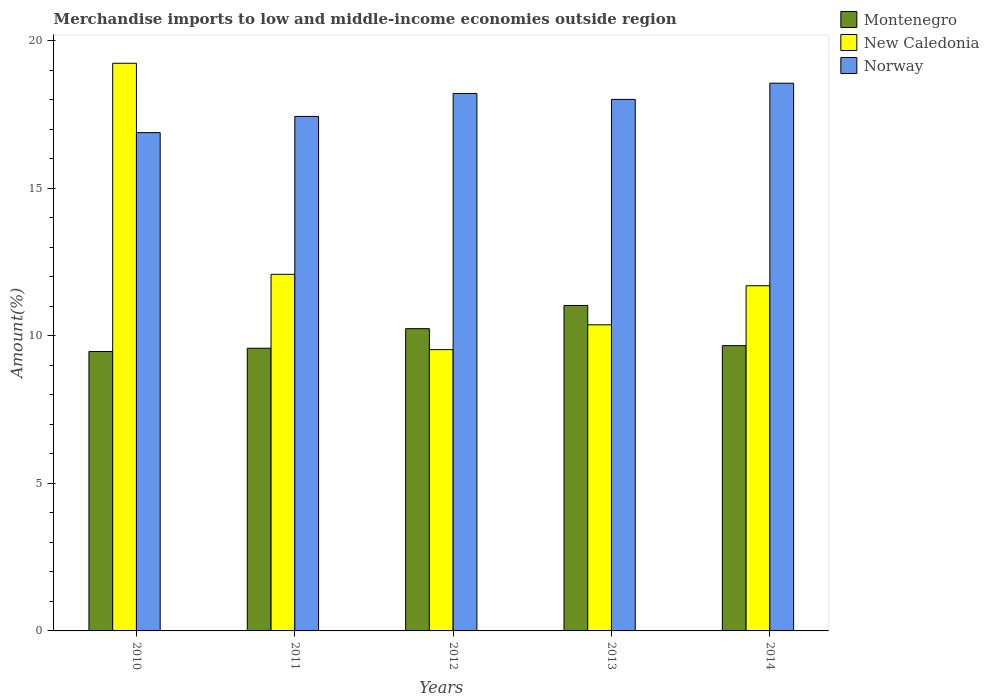How many different coloured bars are there?
Make the answer very short. 3. Are the number of bars on each tick of the X-axis equal?
Your answer should be very brief. Yes. What is the percentage of amount earned from merchandise imports in Montenegro in 2012?
Offer a terse response. 10.25. Across all years, what is the maximum percentage of amount earned from merchandise imports in Norway?
Provide a succinct answer. 18.57. Across all years, what is the minimum percentage of amount earned from merchandise imports in Montenegro?
Make the answer very short. 9.47. In which year was the percentage of amount earned from merchandise imports in Norway minimum?
Offer a terse response. 2010. What is the total percentage of amount earned from merchandise imports in Montenegro in the graph?
Give a very brief answer. 50.01. What is the difference between the percentage of amount earned from merchandise imports in Norway in 2012 and that in 2014?
Provide a succinct answer. -0.35. What is the difference between the percentage of amount earned from merchandise imports in Norway in 2011 and the percentage of amount earned from merchandise imports in Montenegro in 2012?
Give a very brief answer. 7.2. What is the average percentage of amount earned from merchandise imports in New Caledonia per year?
Your answer should be compact. 12.59. In the year 2013, what is the difference between the percentage of amount earned from merchandise imports in Norway and percentage of amount earned from merchandise imports in Montenegro?
Offer a terse response. 6.99. What is the ratio of the percentage of amount earned from merchandise imports in New Caledonia in 2012 to that in 2014?
Provide a succinct answer. 0.81. Is the difference between the percentage of amount earned from merchandise imports in Norway in 2011 and 2012 greater than the difference between the percentage of amount earned from merchandise imports in Montenegro in 2011 and 2012?
Provide a short and direct response. No. What is the difference between the highest and the second highest percentage of amount earned from merchandise imports in Norway?
Offer a very short reply. 0.35. What is the difference between the highest and the lowest percentage of amount earned from merchandise imports in New Caledonia?
Make the answer very short. 9.71. In how many years, is the percentage of amount earned from merchandise imports in Montenegro greater than the average percentage of amount earned from merchandise imports in Montenegro taken over all years?
Provide a succinct answer. 2. Is the sum of the percentage of amount earned from merchandise imports in Montenegro in 2011 and 2012 greater than the maximum percentage of amount earned from merchandise imports in Norway across all years?
Your answer should be compact. Yes. What does the 1st bar from the left in 2010 represents?
Offer a terse response. Montenegro. What does the 3rd bar from the right in 2014 represents?
Keep it short and to the point. Montenegro. Is it the case that in every year, the sum of the percentage of amount earned from merchandise imports in Norway and percentage of amount earned from merchandise imports in New Caledonia is greater than the percentage of amount earned from merchandise imports in Montenegro?
Your response must be concise. Yes. How many bars are there?
Keep it short and to the point. 15. Are all the bars in the graph horizontal?
Offer a terse response. No. What is the difference between two consecutive major ticks on the Y-axis?
Your answer should be very brief. 5. Are the values on the major ticks of Y-axis written in scientific E-notation?
Provide a succinct answer. No. Does the graph contain any zero values?
Offer a very short reply. No. Does the graph contain grids?
Offer a terse response. No. Where does the legend appear in the graph?
Provide a succinct answer. Top right. How are the legend labels stacked?
Your response must be concise. Vertical. What is the title of the graph?
Your answer should be very brief. Merchandise imports to low and middle-income economies outside region. What is the label or title of the Y-axis?
Offer a terse response. Amount(%). What is the Amount(%) in Montenegro in 2010?
Give a very brief answer. 9.47. What is the Amount(%) in New Caledonia in 2010?
Ensure brevity in your answer.  19.25. What is the Amount(%) of Norway in 2010?
Keep it short and to the point. 16.89. What is the Amount(%) of Montenegro in 2011?
Your answer should be compact. 9.58. What is the Amount(%) in New Caledonia in 2011?
Offer a terse response. 12.09. What is the Amount(%) of Norway in 2011?
Provide a succinct answer. 17.44. What is the Amount(%) in Montenegro in 2012?
Your answer should be very brief. 10.25. What is the Amount(%) in New Caledonia in 2012?
Your answer should be compact. 9.54. What is the Amount(%) in Norway in 2012?
Your answer should be compact. 18.22. What is the Amount(%) of Montenegro in 2013?
Keep it short and to the point. 11.03. What is the Amount(%) in New Caledonia in 2013?
Your answer should be very brief. 10.38. What is the Amount(%) in Norway in 2013?
Provide a succinct answer. 18.02. What is the Amount(%) of Montenegro in 2014?
Offer a terse response. 9.67. What is the Amount(%) in New Caledonia in 2014?
Give a very brief answer. 11.7. What is the Amount(%) of Norway in 2014?
Keep it short and to the point. 18.57. Across all years, what is the maximum Amount(%) in Montenegro?
Give a very brief answer. 11.03. Across all years, what is the maximum Amount(%) of New Caledonia?
Your answer should be very brief. 19.25. Across all years, what is the maximum Amount(%) in Norway?
Offer a very short reply. 18.57. Across all years, what is the minimum Amount(%) in Montenegro?
Offer a terse response. 9.47. Across all years, what is the minimum Amount(%) of New Caledonia?
Your response must be concise. 9.54. Across all years, what is the minimum Amount(%) in Norway?
Make the answer very short. 16.89. What is the total Amount(%) of Montenegro in the graph?
Your answer should be very brief. 50.01. What is the total Amount(%) in New Caledonia in the graph?
Your answer should be compact. 62.95. What is the total Amount(%) of Norway in the graph?
Your answer should be compact. 89.15. What is the difference between the Amount(%) of Montenegro in 2010 and that in 2011?
Your answer should be very brief. -0.11. What is the difference between the Amount(%) in New Caledonia in 2010 and that in 2011?
Ensure brevity in your answer.  7.16. What is the difference between the Amount(%) in Norway in 2010 and that in 2011?
Give a very brief answer. -0.55. What is the difference between the Amount(%) in Montenegro in 2010 and that in 2012?
Offer a terse response. -0.77. What is the difference between the Amount(%) in New Caledonia in 2010 and that in 2012?
Your response must be concise. 9.71. What is the difference between the Amount(%) of Norway in 2010 and that in 2012?
Your response must be concise. -1.33. What is the difference between the Amount(%) of Montenegro in 2010 and that in 2013?
Keep it short and to the point. -1.56. What is the difference between the Amount(%) of New Caledonia in 2010 and that in 2013?
Ensure brevity in your answer.  8.87. What is the difference between the Amount(%) in Norway in 2010 and that in 2013?
Your answer should be very brief. -1.13. What is the difference between the Amount(%) of Montenegro in 2010 and that in 2014?
Provide a short and direct response. -0.2. What is the difference between the Amount(%) in New Caledonia in 2010 and that in 2014?
Offer a very short reply. 7.54. What is the difference between the Amount(%) in Norway in 2010 and that in 2014?
Make the answer very short. -1.68. What is the difference between the Amount(%) of Montenegro in 2011 and that in 2012?
Your answer should be very brief. -0.66. What is the difference between the Amount(%) of New Caledonia in 2011 and that in 2012?
Your answer should be very brief. 2.55. What is the difference between the Amount(%) in Norway in 2011 and that in 2012?
Your answer should be very brief. -0.78. What is the difference between the Amount(%) in Montenegro in 2011 and that in 2013?
Offer a very short reply. -1.45. What is the difference between the Amount(%) of New Caledonia in 2011 and that in 2013?
Provide a short and direct response. 1.71. What is the difference between the Amount(%) in Norway in 2011 and that in 2013?
Provide a succinct answer. -0.58. What is the difference between the Amount(%) in Montenegro in 2011 and that in 2014?
Your answer should be very brief. -0.09. What is the difference between the Amount(%) of New Caledonia in 2011 and that in 2014?
Give a very brief answer. 0.39. What is the difference between the Amount(%) of Norway in 2011 and that in 2014?
Make the answer very short. -1.13. What is the difference between the Amount(%) of Montenegro in 2012 and that in 2013?
Your answer should be very brief. -0.79. What is the difference between the Amount(%) in New Caledonia in 2012 and that in 2013?
Your answer should be very brief. -0.84. What is the difference between the Amount(%) of Norway in 2012 and that in 2013?
Your answer should be very brief. 0.2. What is the difference between the Amount(%) in Montenegro in 2012 and that in 2014?
Offer a very short reply. 0.58. What is the difference between the Amount(%) of New Caledonia in 2012 and that in 2014?
Make the answer very short. -2.17. What is the difference between the Amount(%) of Norway in 2012 and that in 2014?
Ensure brevity in your answer.  -0.35. What is the difference between the Amount(%) of Montenegro in 2013 and that in 2014?
Offer a very short reply. 1.36. What is the difference between the Amount(%) of New Caledonia in 2013 and that in 2014?
Provide a succinct answer. -1.32. What is the difference between the Amount(%) in Norway in 2013 and that in 2014?
Make the answer very short. -0.55. What is the difference between the Amount(%) of Montenegro in 2010 and the Amount(%) of New Caledonia in 2011?
Ensure brevity in your answer.  -2.62. What is the difference between the Amount(%) of Montenegro in 2010 and the Amount(%) of Norway in 2011?
Provide a short and direct response. -7.97. What is the difference between the Amount(%) in New Caledonia in 2010 and the Amount(%) in Norway in 2011?
Your response must be concise. 1.8. What is the difference between the Amount(%) of Montenegro in 2010 and the Amount(%) of New Caledonia in 2012?
Ensure brevity in your answer.  -0.06. What is the difference between the Amount(%) of Montenegro in 2010 and the Amount(%) of Norway in 2012?
Keep it short and to the point. -8.75. What is the difference between the Amount(%) in New Caledonia in 2010 and the Amount(%) in Norway in 2012?
Provide a succinct answer. 1.02. What is the difference between the Amount(%) of Montenegro in 2010 and the Amount(%) of New Caledonia in 2013?
Your answer should be compact. -0.9. What is the difference between the Amount(%) of Montenegro in 2010 and the Amount(%) of Norway in 2013?
Give a very brief answer. -8.55. What is the difference between the Amount(%) in New Caledonia in 2010 and the Amount(%) in Norway in 2013?
Your response must be concise. 1.22. What is the difference between the Amount(%) of Montenegro in 2010 and the Amount(%) of New Caledonia in 2014?
Provide a succinct answer. -2.23. What is the difference between the Amount(%) of Montenegro in 2010 and the Amount(%) of Norway in 2014?
Ensure brevity in your answer.  -9.1. What is the difference between the Amount(%) in New Caledonia in 2010 and the Amount(%) in Norway in 2014?
Give a very brief answer. 0.68. What is the difference between the Amount(%) of Montenegro in 2011 and the Amount(%) of New Caledonia in 2012?
Provide a succinct answer. 0.05. What is the difference between the Amount(%) in Montenegro in 2011 and the Amount(%) in Norway in 2012?
Offer a very short reply. -8.64. What is the difference between the Amount(%) of New Caledonia in 2011 and the Amount(%) of Norway in 2012?
Your answer should be compact. -6.13. What is the difference between the Amount(%) in Montenegro in 2011 and the Amount(%) in New Caledonia in 2013?
Give a very brief answer. -0.79. What is the difference between the Amount(%) of Montenegro in 2011 and the Amount(%) of Norway in 2013?
Offer a terse response. -8.44. What is the difference between the Amount(%) of New Caledonia in 2011 and the Amount(%) of Norway in 2013?
Keep it short and to the point. -5.93. What is the difference between the Amount(%) in Montenegro in 2011 and the Amount(%) in New Caledonia in 2014?
Make the answer very short. -2.12. What is the difference between the Amount(%) in Montenegro in 2011 and the Amount(%) in Norway in 2014?
Your answer should be very brief. -8.98. What is the difference between the Amount(%) in New Caledonia in 2011 and the Amount(%) in Norway in 2014?
Your answer should be very brief. -6.48. What is the difference between the Amount(%) in Montenegro in 2012 and the Amount(%) in New Caledonia in 2013?
Give a very brief answer. -0.13. What is the difference between the Amount(%) in Montenegro in 2012 and the Amount(%) in Norway in 2013?
Give a very brief answer. -7.77. What is the difference between the Amount(%) in New Caledonia in 2012 and the Amount(%) in Norway in 2013?
Offer a very short reply. -8.48. What is the difference between the Amount(%) in Montenegro in 2012 and the Amount(%) in New Caledonia in 2014?
Your answer should be very brief. -1.46. What is the difference between the Amount(%) of Montenegro in 2012 and the Amount(%) of Norway in 2014?
Offer a terse response. -8.32. What is the difference between the Amount(%) of New Caledonia in 2012 and the Amount(%) of Norway in 2014?
Ensure brevity in your answer.  -9.03. What is the difference between the Amount(%) of Montenegro in 2013 and the Amount(%) of New Caledonia in 2014?
Provide a short and direct response. -0.67. What is the difference between the Amount(%) of Montenegro in 2013 and the Amount(%) of Norway in 2014?
Your answer should be compact. -7.54. What is the difference between the Amount(%) of New Caledonia in 2013 and the Amount(%) of Norway in 2014?
Provide a short and direct response. -8.19. What is the average Amount(%) in Montenegro per year?
Offer a very short reply. 10. What is the average Amount(%) of New Caledonia per year?
Your response must be concise. 12.59. What is the average Amount(%) in Norway per year?
Make the answer very short. 17.83. In the year 2010, what is the difference between the Amount(%) in Montenegro and Amount(%) in New Caledonia?
Your answer should be compact. -9.77. In the year 2010, what is the difference between the Amount(%) in Montenegro and Amount(%) in Norway?
Keep it short and to the point. -7.42. In the year 2010, what is the difference between the Amount(%) of New Caledonia and Amount(%) of Norway?
Your answer should be compact. 2.35. In the year 2011, what is the difference between the Amount(%) in Montenegro and Amount(%) in New Caledonia?
Keep it short and to the point. -2.51. In the year 2011, what is the difference between the Amount(%) in Montenegro and Amount(%) in Norway?
Ensure brevity in your answer.  -7.86. In the year 2011, what is the difference between the Amount(%) in New Caledonia and Amount(%) in Norway?
Your answer should be very brief. -5.35. In the year 2012, what is the difference between the Amount(%) of Montenegro and Amount(%) of New Caledonia?
Ensure brevity in your answer.  0.71. In the year 2012, what is the difference between the Amount(%) of Montenegro and Amount(%) of Norway?
Offer a very short reply. -7.97. In the year 2012, what is the difference between the Amount(%) in New Caledonia and Amount(%) in Norway?
Keep it short and to the point. -8.68. In the year 2013, what is the difference between the Amount(%) of Montenegro and Amount(%) of New Caledonia?
Keep it short and to the point. 0.66. In the year 2013, what is the difference between the Amount(%) of Montenegro and Amount(%) of Norway?
Make the answer very short. -6.99. In the year 2013, what is the difference between the Amount(%) of New Caledonia and Amount(%) of Norway?
Your answer should be compact. -7.64. In the year 2014, what is the difference between the Amount(%) in Montenegro and Amount(%) in New Caledonia?
Offer a terse response. -2.03. In the year 2014, what is the difference between the Amount(%) in Montenegro and Amount(%) in Norway?
Offer a terse response. -8.9. In the year 2014, what is the difference between the Amount(%) in New Caledonia and Amount(%) in Norway?
Keep it short and to the point. -6.87. What is the ratio of the Amount(%) of Montenegro in 2010 to that in 2011?
Provide a short and direct response. 0.99. What is the ratio of the Amount(%) in New Caledonia in 2010 to that in 2011?
Make the answer very short. 1.59. What is the ratio of the Amount(%) of Norway in 2010 to that in 2011?
Offer a terse response. 0.97. What is the ratio of the Amount(%) in Montenegro in 2010 to that in 2012?
Provide a succinct answer. 0.92. What is the ratio of the Amount(%) of New Caledonia in 2010 to that in 2012?
Your response must be concise. 2.02. What is the ratio of the Amount(%) in Norway in 2010 to that in 2012?
Your response must be concise. 0.93. What is the ratio of the Amount(%) in Montenegro in 2010 to that in 2013?
Make the answer very short. 0.86. What is the ratio of the Amount(%) in New Caledonia in 2010 to that in 2013?
Give a very brief answer. 1.85. What is the ratio of the Amount(%) in Norway in 2010 to that in 2013?
Keep it short and to the point. 0.94. What is the ratio of the Amount(%) of Montenegro in 2010 to that in 2014?
Your response must be concise. 0.98. What is the ratio of the Amount(%) of New Caledonia in 2010 to that in 2014?
Ensure brevity in your answer.  1.64. What is the ratio of the Amount(%) in Norway in 2010 to that in 2014?
Give a very brief answer. 0.91. What is the ratio of the Amount(%) of Montenegro in 2011 to that in 2012?
Keep it short and to the point. 0.94. What is the ratio of the Amount(%) of New Caledonia in 2011 to that in 2012?
Your answer should be compact. 1.27. What is the ratio of the Amount(%) in Norway in 2011 to that in 2012?
Your answer should be compact. 0.96. What is the ratio of the Amount(%) in Montenegro in 2011 to that in 2013?
Give a very brief answer. 0.87. What is the ratio of the Amount(%) of New Caledonia in 2011 to that in 2013?
Provide a short and direct response. 1.16. What is the ratio of the Amount(%) in Norway in 2011 to that in 2013?
Give a very brief answer. 0.97. What is the ratio of the Amount(%) in New Caledonia in 2011 to that in 2014?
Offer a terse response. 1.03. What is the ratio of the Amount(%) of Norway in 2011 to that in 2014?
Offer a very short reply. 0.94. What is the ratio of the Amount(%) in Montenegro in 2012 to that in 2013?
Offer a very short reply. 0.93. What is the ratio of the Amount(%) in New Caledonia in 2012 to that in 2013?
Your answer should be compact. 0.92. What is the ratio of the Amount(%) of Norway in 2012 to that in 2013?
Your answer should be very brief. 1.01. What is the ratio of the Amount(%) in Montenegro in 2012 to that in 2014?
Provide a succinct answer. 1.06. What is the ratio of the Amount(%) of New Caledonia in 2012 to that in 2014?
Your answer should be very brief. 0.81. What is the ratio of the Amount(%) in Norway in 2012 to that in 2014?
Give a very brief answer. 0.98. What is the ratio of the Amount(%) of Montenegro in 2013 to that in 2014?
Provide a succinct answer. 1.14. What is the ratio of the Amount(%) in New Caledonia in 2013 to that in 2014?
Offer a terse response. 0.89. What is the ratio of the Amount(%) of Norway in 2013 to that in 2014?
Provide a succinct answer. 0.97. What is the difference between the highest and the second highest Amount(%) in Montenegro?
Give a very brief answer. 0.79. What is the difference between the highest and the second highest Amount(%) in New Caledonia?
Offer a terse response. 7.16. What is the difference between the highest and the second highest Amount(%) in Norway?
Your answer should be compact. 0.35. What is the difference between the highest and the lowest Amount(%) of Montenegro?
Your response must be concise. 1.56. What is the difference between the highest and the lowest Amount(%) in New Caledonia?
Keep it short and to the point. 9.71. What is the difference between the highest and the lowest Amount(%) in Norway?
Your answer should be compact. 1.68. 